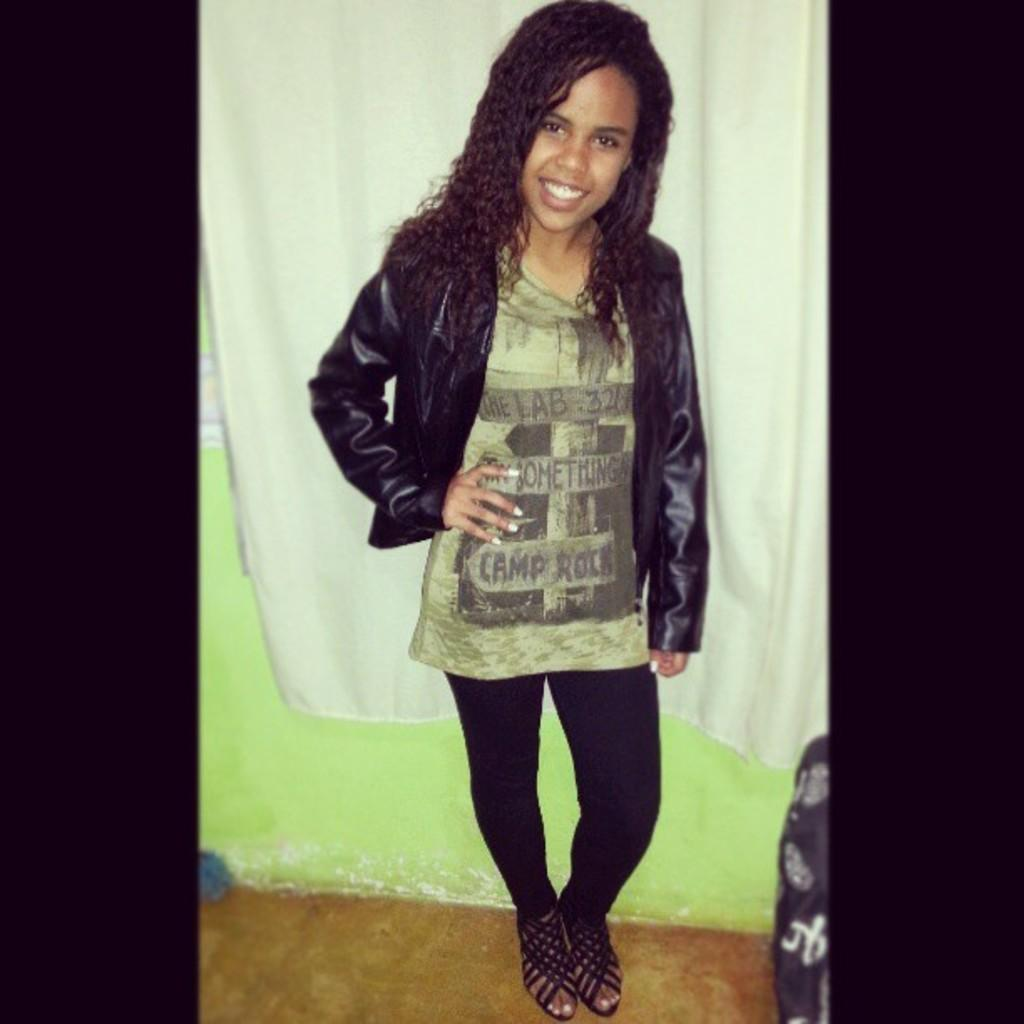Who is the main subject in the image? There is a girl in the image. What is the girl doing in the image? The girl is standing on the floor, smiling, and giving a pose for the picture. What can be seen in the background of the image? There is a white color curtain in the background. How is the curtain positioned in the image? The curtain is attached to a wall. What type of adjustment is the girl making to the scissors in the image? There are no scissors present in the image, so no adjustment can be observed. 